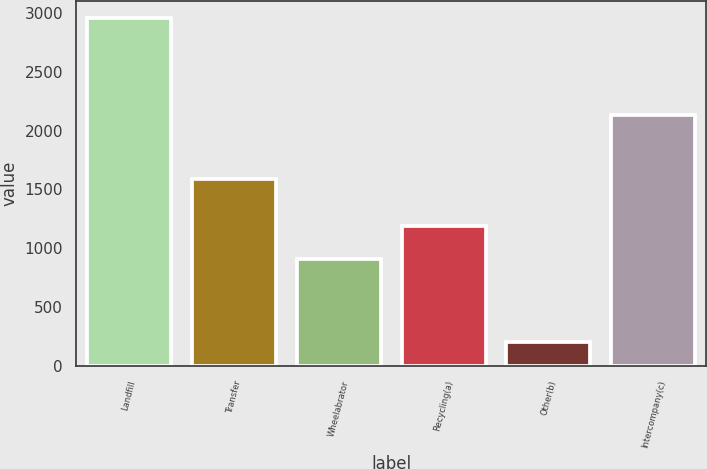Convert chart. <chart><loc_0><loc_0><loc_500><loc_500><bar_chart><fcel>Landfill<fcel>Transfer<fcel>Wheelabrator<fcel>Recycling(a)<fcel>Other(b)<fcel>Intercompany(c)<nl><fcel>2955<fcel>1589<fcel>912<fcel>1186.8<fcel>207<fcel>2134<nl></chart> 